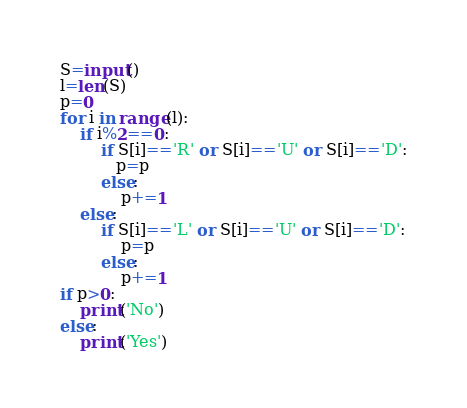Convert code to text. <code><loc_0><loc_0><loc_500><loc_500><_Python_>S=input()
l=len(S)
p=0
for i in range(l):
    if i%2==0:
        if S[i]=='R' or S[i]=='U' or S[i]=='D':
           p=p
        else:
            p+=1
    else:
        if S[i]=='L' or S[i]=='U' or S[i]=='D':
            p=p
        else:
            p+=1
if p>0:
    print('No')
else:
    print('Yes')</code> 